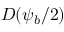<formula> <loc_0><loc_0><loc_500><loc_500>D ( \psi _ { b } / 2 )</formula> 